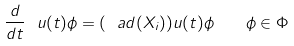Convert formula to latex. <formula><loc_0><loc_0><loc_500><loc_500>\frac { d } { d t } \ u ( t ) \phi = ( \ a d ( X _ { i } ) ) u ( t ) \phi \quad \phi \in \Phi</formula> 